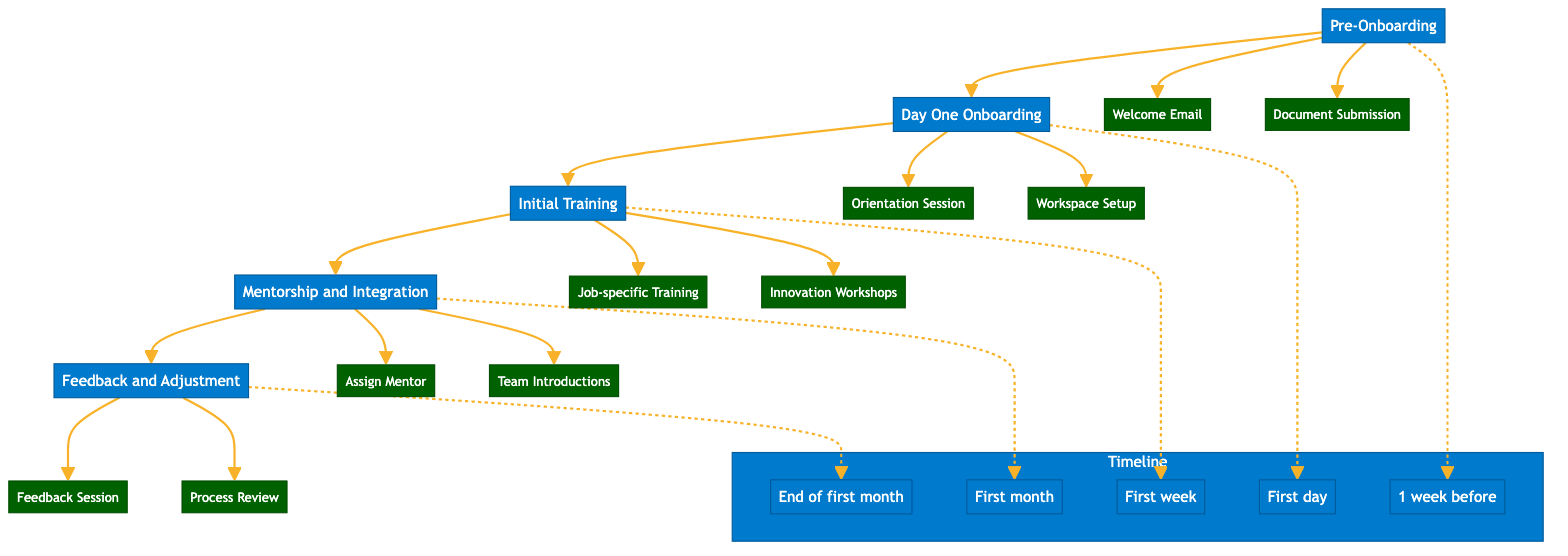What is the first step in the onboarding process? The diagram clearly indicates that the first step in the onboarding process is "Pre-Onboarding."
Answer: Pre-Onboarding How many substeps are included in the "Initial Training" step? By examining the "Initial Training" node, there are two substeps listed: "Job-specific Training" and "Innovation Workshops." Therefore, the total is 2.
Answer: 2 What timeline is associated with "Mentorship and Integration"? The diagram denotes that "Mentorship and Integration" takes place during the "First month."
Answer: First month Which substep comes after "Orientation Session"? Following the "Orientation Session" under "Day One Onboarding," the next substep listed is "Workspace Setup."
Answer: Workspace Setup What is the last step in the onboarding process? The final step depicted in the onboarding process is "Feedback and Adjustment."
Answer: Feedback and Adjustment How many total steps are in the onboarding process? The diagram shows that there are five main steps in the onboarding process: "Pre-Onboarding," "Day One Onboarding," "Initial Training," "Mentorship and Integration," and "Feedback and Adjustment." Therefore, the total count is 5.
Answer: 5 What is the relationship between "Feedback Session" and "Process Review"? In the diagram, both "Feedback Session" and "Process Review" are substeps that fall under the "Feedback and Adjustment" main step. This indicates they are sequential activities that occur within the same phase.
Answer: Substeps At what point in time is "Document Submission" expected to be completed? The diagram specifies that "Document Submission" is to be completed 1 week before the start date.
Answer: 1 week before 